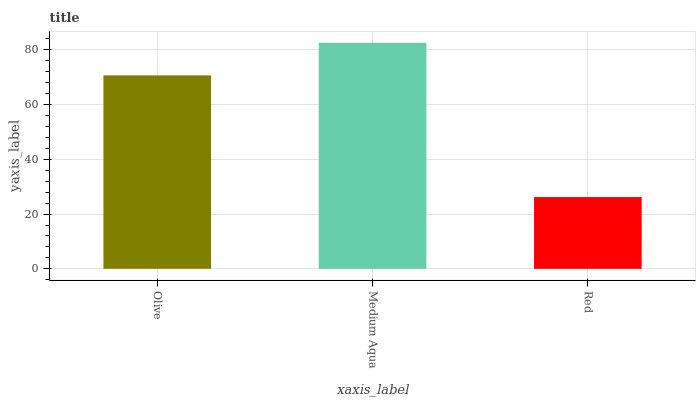Is Red the minimum?
Answer yes or no. Yes. Is Medium Aqua the maximum?
Answer yes or no. Yes. Is Medium Aqua the minimum?
Answer yes or no. No. Is Red the maximum?
Answer yes or no. No. Is Medium Aqua greater than Red?
Answer yes or no. Yes. Is Red less than Medium Aqua?
Answer yes or no. Yes. Is Red greater than Medium Aqua?
Answer yes or no. No. Is Medium Aqua less than Red?
Answer yes or no. No. Is Olive the high median?
Answer yes or no. Yes. Is Olive the low median?
Answer yes or no. Yes. Is Medium Aqua the high median?
Answer yes or no. No. Is Medium Aqua the low median?
Answer yes or no. No. 